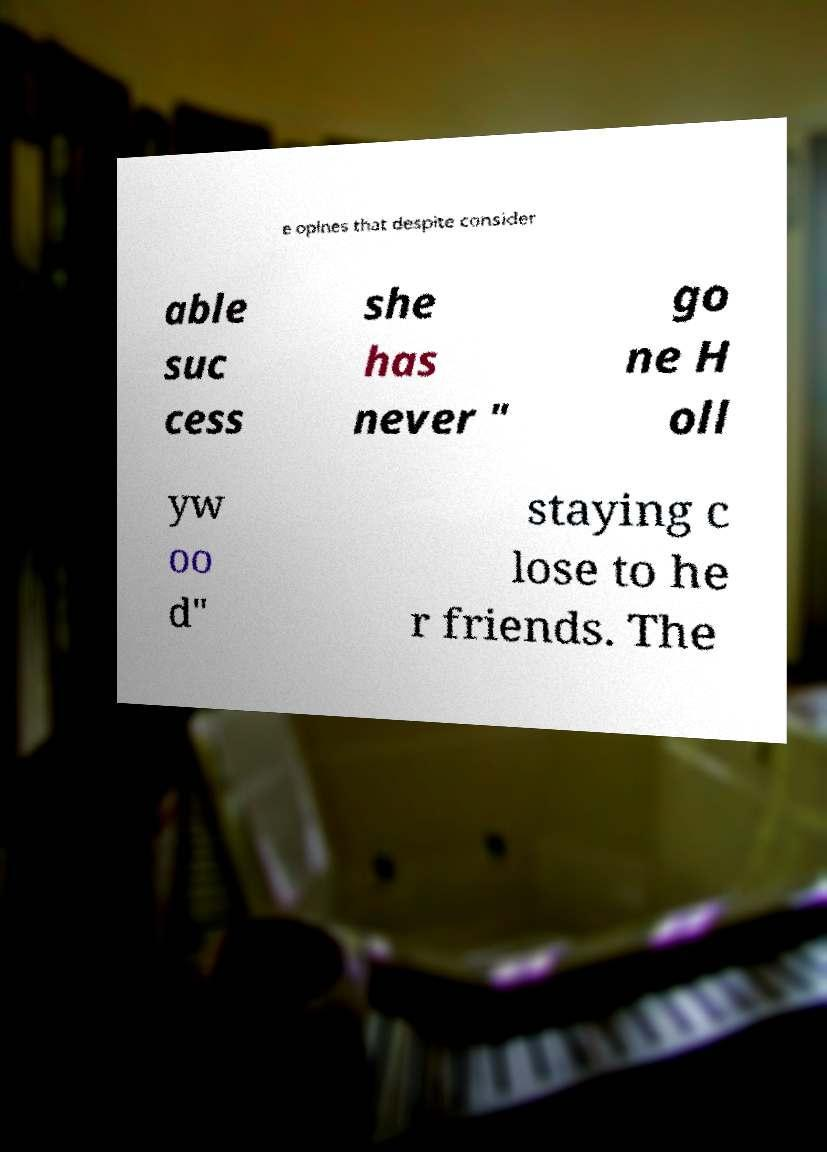Could you assist in decoding the text presented in this image and type it out clearly? e opines that despite consider able suc cess she has never " go ne H oll yw oo d" staying c lose to he r friends. The 